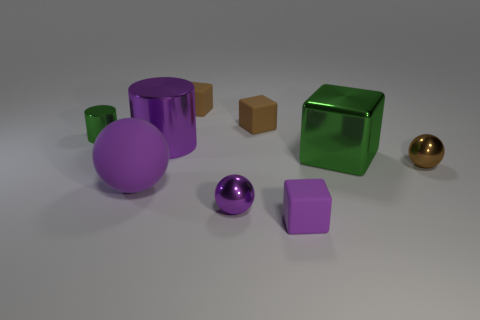Subtract all large rubber spheres. How many spheres are left? 2 Subtract all spheres. How many objects are left? 6 Add 1 small purple matte blocks. How many objects exist? 10 Subtract all green cylinders. How many cylinders are left? 1 Subtract 0 blue blocks. How many objects are left? 9 Subtract 2 cylinders. How many cylinders are left? 0 Subtract all green blocks. Subtract all red balls. How many blocks are left? 3 Subtract all purple blocks. How many green balls are left? 0 Subtract all small green metal objects. Subtract all small blue matte cubes. How many objects are left? 8 Add 9 large green shiny cubes. How many large green shiny cubes are left? 10 